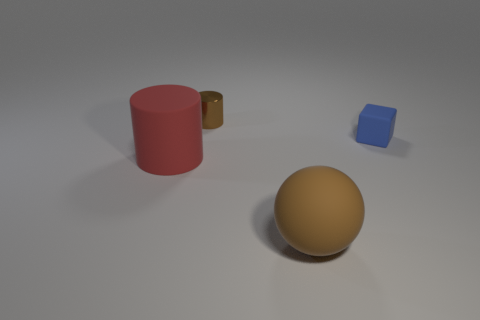Subtract all red cylinders. How many cylinders are left? 1 Add 1 brown metallic cylinders. How many objects exist? 5 Subtract all balls. How many objects are left? 3 Add 1 cyan things. How many cyan things exist? 1 Subtract 0 green cubes. How many objects are left? 4 Subtract all green cylinders. Subtract all brown spheres. How many cylinders are left? 2 Subtract all purple spheres. How many brown cylinders are left? 1 Subtract all big cylinders. Subtract all tiny blue matte cubes. How many objects are left? 2 Add 2 large spheres. How many large spheres are left? 3 